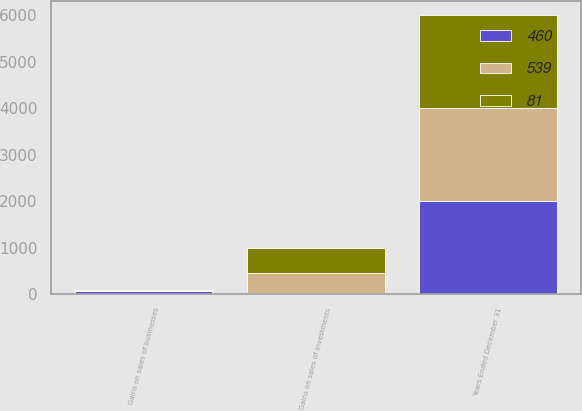Convert chart. <chart><loc_0><loc_0><loc_500><loc_500><stacked_bar_chart><ecel><fcel>Years Ended December 31<fcel>Gains on sales of investments<fcel>Gains on sales of businesses<nl><fcel>539<fcel>2004<fcel>434<fcel>26<nl><fcel>81<fcel>2003<fcel>524<fcel>15<nl><fcel>460<fcel>2002<fcel>27<fcel>54<nl></chart> 